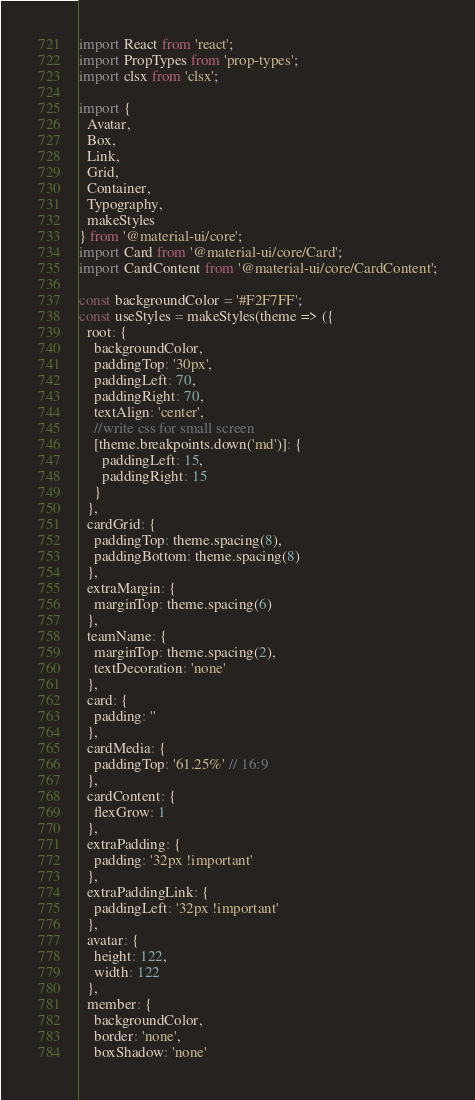Convert code to text. <code><loc_0><loc_0><loc_500><loc_500><_JavaScript_>import React from 'react';
import PropTypes from 'prop-types';
import clsx from 'clsx';

import {
  Avatar,
  Box,
  Link,
  Grid,
  Container,
  Typography,
  makeStyles
} from '@material-ui/core';
import Card from '@material-ui/core/Card';
import CardContent from '@material-ui/core/CardContent';

const backgroundColor = '#F2F7FF';
const useStyles = makeStyles(theme => ({
  root: {
    backgroundColor,
    paddingTop: '30px',
    paddingLeft: 70,
    paddingRight: 70,
    textAlign: 'center',
    //write css for small screen
    [theme.breakpoints.down('md')]: {
      paddingLeft: 15,
      paddingRight: 15
    }
  },
  cardGrid: {
    paddingTop: theme.spacing(8),
    paddingBottom: theme.spacing(8)
  },
  extraMargin: {
    marginTop: theme.spacing(6)
  },
  teamName: {
    marginTop: theme.spacing(2),
    textDecoration: 'none'
  },
  card: {
    padding: ''
  },
  cardMedia: {
    paddingTop: '61.25%' // 16:9
  },
  cardContent: {
    flexGrow: 1
  },
  extraPadding: {
    padding: '32px !important'
  },
  extraPaddingLink: {
    paddingLeft: '32px !important'
  },
  avatar: {
    height: 122,
    width: 122
  },
  member: {
    backgroundColor,
    border: 'none',
    boxShadow: 'none'</code> 